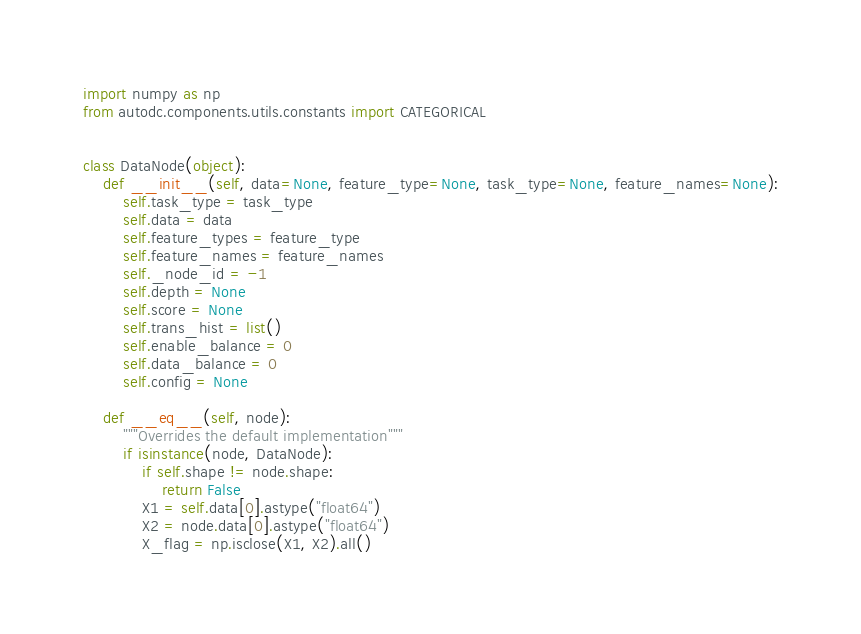<code> <loc_0><loc_0><loc_500><loc_500><_Python_>import numpy as np
from autodc.components.utils.constants import CATEGORICAL


class DataNode(object):
    def __init__(self, data=None, feature_type=None, task_type=None, feature_names=None):
        self.task_type = task_type
        self.data = data
        self.feature_types = feature_type
        self.feature_names = feature_names
        self._node_id = -1
        self.depth = None
        self.score = None
        self.trans_hist = list()
        self.enable_balance = 0
        self.data_balance = 0
        self.config = None

    def __eq__(self, node):
        """Overrides the default implementation"""
        if isinstance(node, DataNode):
            if self.shape != node.shape:
                return False
            X1 = self.data[0].astype("float64")
            X2 = node.data[0].astype("float64")
            X_flag = np.isclose(X1, X2).all()</code> 